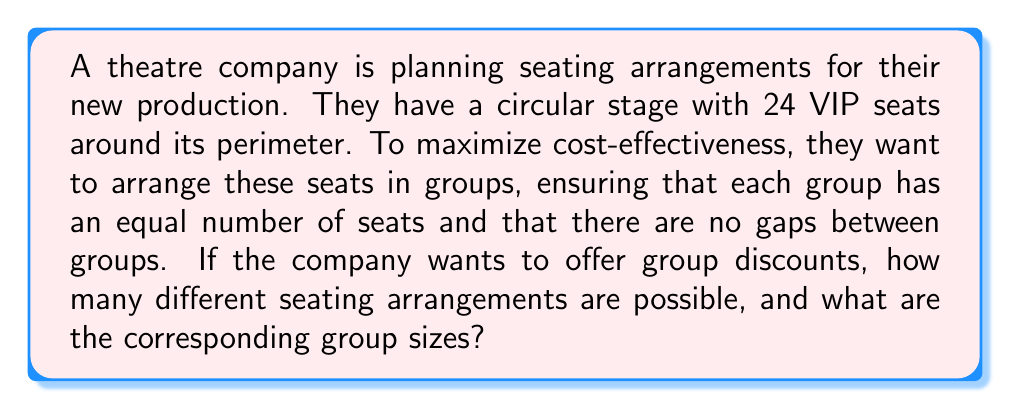Give your solution to this math problem. To solve this problem, we need to use concepts from modular arithmetic and divisibility.

1) First, we need to find the divisors of 24, as these will represent the possible group sizes:
   Divisors of 24 = {1, 2, 3, 4, 6, 8, 12, 24}

2) Now, we need to consider which of these divisors will result in valid seating arrangements without gaps. This is where modular arithmetic comes in.

3) For a seating arrangement to be valid, the number of seats (24) must be divisible by the group size with no remainder. In modular arithmetic terms:

   $24 \equiv 0 \pmod{d}$, where $d$ is the divisor (group size)

4) This condition is satisfied by all divisors of 24, so all of the divisors we found in step 1 are valid.

5) Let's break down what each arrangement would look like:
   - 1 seat per group: 24 groups of 1 (trivial case)
   - 2 seats per group: 12 groups of 2
   - 3 seats per group: 8 groups of 3
   - 4 seats per group: 6 groups of 4
   - 6 seats per group: 4 groups of 6
   - 8 seats per group: 3 groups of 8
   - 12 seats per group: 2 groups of 12
   - 24 seats per group: 1 group of 24 (trivial case)

6) Therefore, there are 8 different possible seating arrangements.

From a cost-effectiveness standpoint, the theatre company might prefer arrangements with more groups (like 12 groups of 2 or 8 groups of 3) as this allows for more flexible pricing and potentially higher overall revenue. However, larger group sizes might be more attractive for families or larger parties, potentially leading to more sales. The optimal choice would depend on the specific financial goals and target audience of the production.
Answer: There are 8 different possible seating arrangements, with group sizes of 1, 2, 3, 4, 6, 8, 12, and 24 seats. 